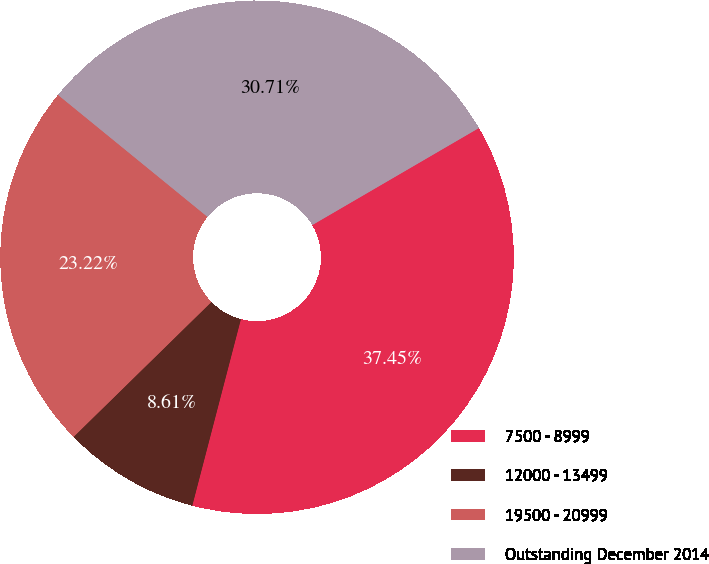<chart> <loc_0><loc_0><loc_500><loc_500><pie_chart><fcel>7500 - 8999<fcel>12000 - 13499<fcel>19500 - 20999<fcel>Outstanding December 2014<nl><fcel>37.45%<fcel>8.61%<fcel>23.22%<fcel>30.71%<nl></chart> 